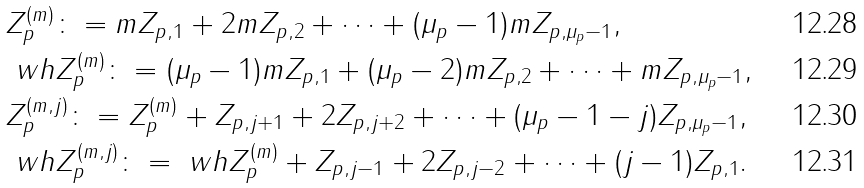<formula> <loc_0><loc_0><loc_500><loc_500>& Z _ { p } ^ { ( m ) } \colon = m Z _ { p , 1 } + 2 m Z _ { p , 2 } + \cdots + ( \mu _ { p } - 1 ) m Z _ { p , \mu _ { p } - 1 } , \\ & \ w h Z _ { p } ^ { ( m ) } \colon = ( \mu _ { p } - 1 ) m Z _ { p , 1 } + ( \mu _ { p } - 2 ) m Z _ { p , 2 } + \cdots + m Z _ { p , \mu _ { p } - 1 } , \\ & Z _ { p } ^ { ( m , j ) } \colon = Z _ { p } ^ { ( m ) } + Z _ { p , j + 1 } + 2 Z _ { p , j + 2 } + \cdots + ( \mu _ { p } - 1 - j ) Z _ { p , \mu _ { p } - 1 } , \\ & \ w h Z _ { p } ^ { ( m , j ) } \colon = \ w h Z _ { p } ^ { ( m ) } + Z _ { p , j - 1 } + 2 Z _ { p , j - 2 } + \cdots + ( j - 1 ) Z _ { p , 1 } .</formula> 